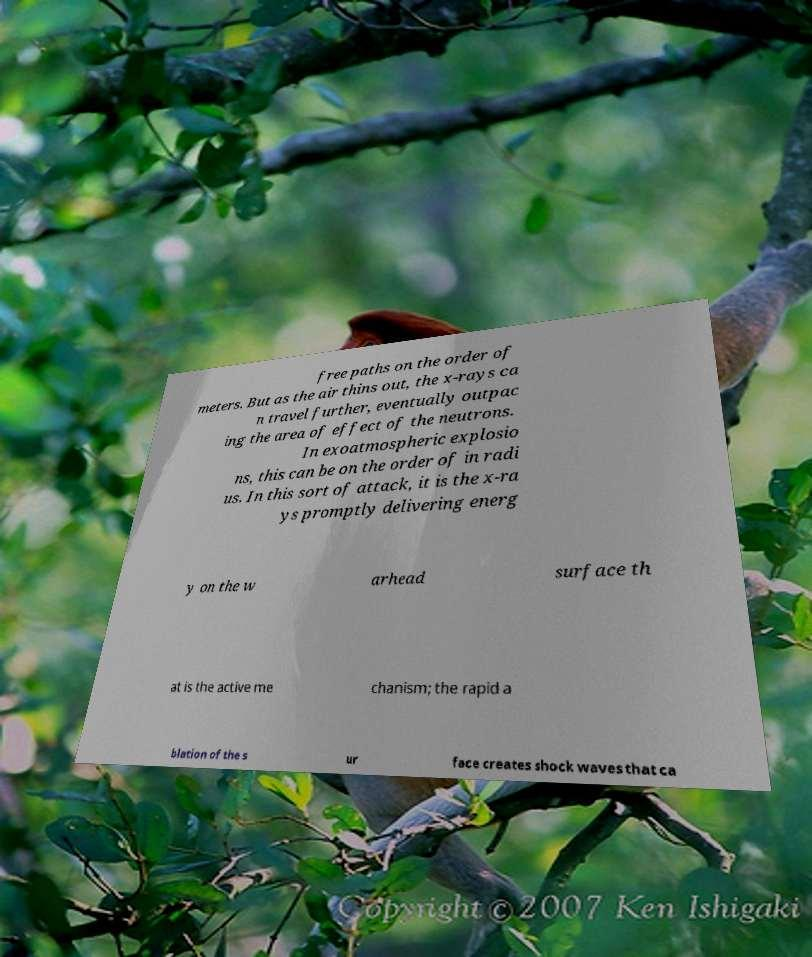Can you accurately transcribe the text from the provided image for me? free paths on the order of meters. But as the air thins out, the x-rays ca n travel further, eventually outpac ing the area of effect of the neutrons. In exoatmospheric explosio ns, this can be on the order of in radi us. In this sort of attack, it is the x-ra ys promptly delivering energ y on the w arhead surface th at is the active me chanism; the rapid a blation of the s ur face creates shock waves that ca 